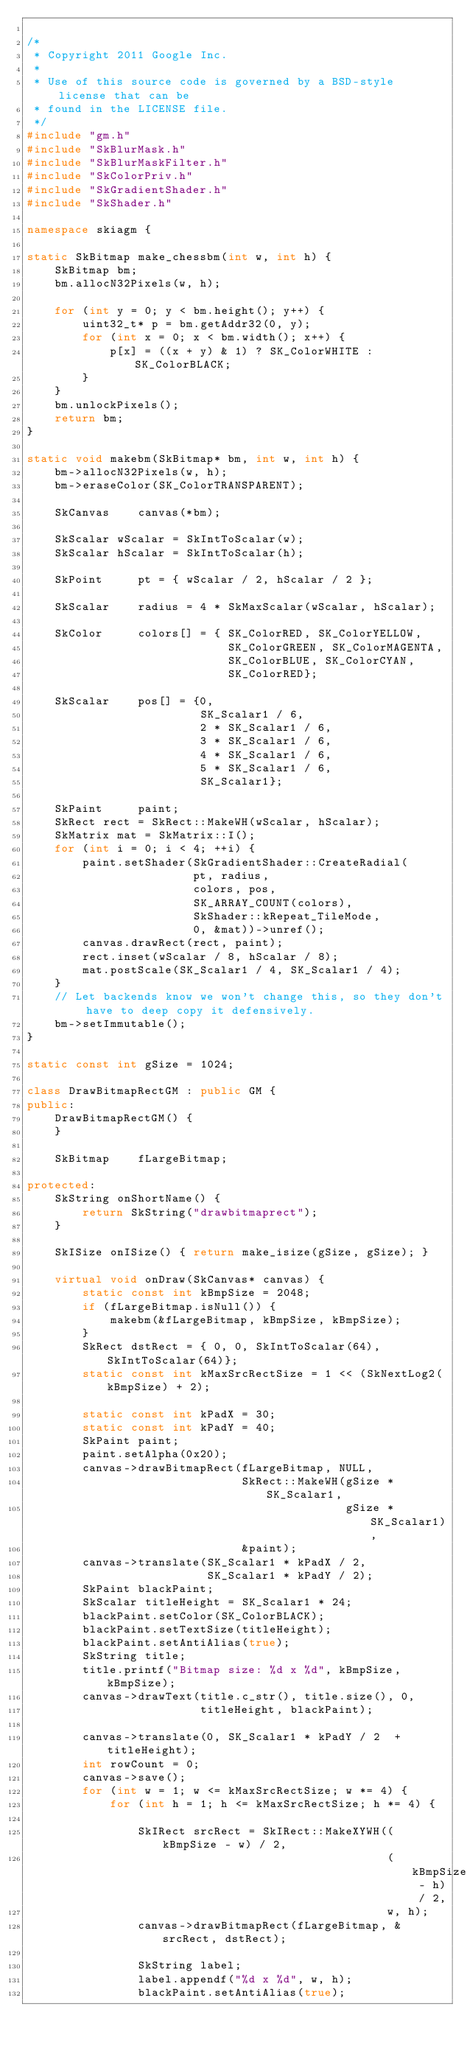Convert code to text. <code><loc_0><loc_0><loc_500><loc_500><_C++_>
/*
 * Copyright 2011 Google Inc.
 *
 * Use of this source code is governed by a BSD-style license that can be
 * found in the LICENSE file.
 */
#include "gm.h"
#include "SkBlurMask.h"
#include "SkBlurMaskFilter.h"
#include "SkColorPriv.h"
#include "SkGradientShader.h"
#include "SkShader.h"

namespace skiagm {

static SkBitmap make_chessbm(int w, int h) {
    SkBitmap bm;
    bm.allocN32Pixels(w, h);

    for (int y = 0; y < bm.height(); y++) {
        uint32_t* p = bm.getAddr32(0, y);
        for (int x = 0; x < bm.width(); x++) {
            p[x] = ((x + y) & 1) ? SK_ColorWHITE : SK_ColorBLACK;
        }
    }
    bm.unlockPixels();
    return bm;
}

static void makebm(SkBitmap* bm, int w, int h) {
    bm->allocN32Pixels(w, h);
    bm->eraseColor(SK_ColorTRANSPARENT);

    SkCanvas    canvas(*bm);

    SkScalar wScalar = SkIntToScalar(w);
    SkScalar hScalar = SkIntToScalar(h);

    SkPoint     pt = { wScalar / 2, hScalar / 2 };

    SkScalar    radius = 4 * SkMaxScalar(wScalar, hScalar);

    SkColor     colors[] = { SK_ColorRED, SK_ColorYELLOW,
                             SK_ColorGREEN, SK_ColorMAGENTA,
                             SK_ColorBLUE, SK_ColorCYAN,
                             SK_ColorRED};

    SkScalar    pos[] = {0,
                         SK_Scalar1 / 6,
                         2 * SK_Scalar1 / 6,
                         3 * SK_Scalar1 / 6,
                         4 * SK_Scalar1 / 6,
                         5 * SK_Scalar1 / 6,
                         SK_Scalar1};

    SkPaint     paint;
    SkRect rect = SkRect::MakeWH(wScalar, hScalar);
    SkMatrix mat = SkMatrix::I();
    for (int i = 0; i < 4; ++i) {
        paint.setShader(SkGradientShader::CreateRadial(
                        pt, radius,
                        colors, pos,
                        SK_ARRAY_COUNT(colors),
                        SkShader::kRepeat_TileMode,
                        0, &mat))->unref();
        canvas.drawRect(rect, paint);
        rect.inset(wScalar / 8, hScalar / 8);
        mat.postScale(SK_Scalar1 / 4, SK_Scalar1 / 4);
    }
    // Let backends know we won't change this, so they don't have to deep copy it defensively.
    bm->setImmutable();
}

static const int gSize = 1024;

class DrawBitmapRectGM : public GM {
public:
    DrawBitmapRectGM() {
    }

    SkBitmap    fLargeBitmap;

protected:
    SkString onShortName() {
        return SkString("drawbitmaprect");
    }

    SkISize onISize() { return make_isize(gSize, gSize); }

    virtual void onDraw(SkCanvas* canvas) {
        static const int kBmpSize = 2048;
        if (fLargeBitmap.isNull()) {
            makebm(&fLargeBitmap, kBmpSize, kBmpSize);
        }
        SkRect dstRect = { 0, 0, SkIntToScalar(64), SkIntToScalar(64)};
        static const int kMaxSrcRectSize = 1 << (SkNextLog2(kBmpSize) + 2);

        static const int kPadX = 30;
        static const int kPadY = 40;
        SkPaint paint;
        paint.setAlpha(0x20);
        canvas->drawBitmapRect(fLargeBitmap, NULL,
                               SkRect::MakeWH(gSize * SK_Scalar1,
                                              gSize * SK_Scalar1),
                               &paint);
        canvas->translate(SK_Scalar1 * kPadX / 2,
                          SK_Scalar1 * kPadY / 2);
        SkPaint blackPaint;
        SkScalar titleHeight = SK_Scalar1 * 24;
        blackPaint.setColor(SK_ColorBLACK);
        blackPaint.setTextSize(titleHeight);
        blackPaint.setAntiAlias(true);
        SkString title;
        title.printf("Bitmap size: %d x %d", kBmpSize, kBmpSize);
        canvas->drawText(title.c_str(), title.size(), 0,
                         titleHeight, blackPaint);

        canvas->translate(0, SK_Scalar1 * kPadY / 2  + titleHeight);
        int rowCount = 0;
        canvas->save();
        for (int w = 1; w <= kMaxSrcRectSize; w *= 4) {
            for (int h = 1; h <= kMaxSrcRectSize; h *= 4) {

                SkIRect srcRect = SkIRect::MakeXYWH((kBmpSize - w) / 2,
                                                    (kBmpSize - h) / 2,
                                                    w, h);
                canvas->drawBitmapRect(fLargeBitmap, &srcRect, dstRect);

                SkString label;
                label.appendf("%d x %d", w, h);
                blackPaint.setAntiAlias(true);</code> 